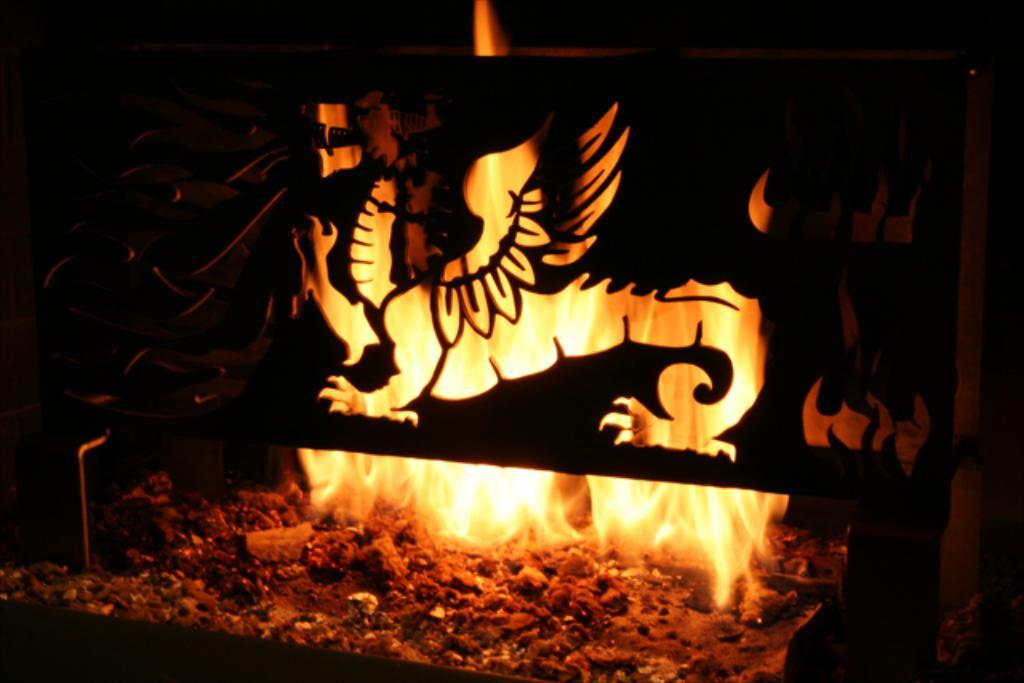What is the main feature of the image? There is a fireplace in the image. Is there any additional furniture or equipment related to the fireplace? Yes, there is a stand associated with the fireplace in the image. What type of grain is being fed to the horse in the image? There is no horse or grain present in the image; it only features a fireplace and a stand. 